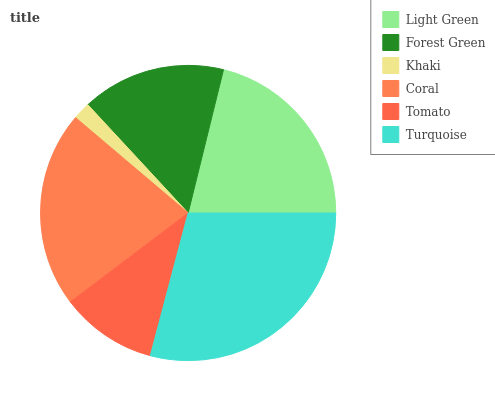Is Khaki the minimum?
Answer yes or no. Yes. Is Turquoise the maximum?
Answer yes or no. Yes. Is Forest Green the minimum?
Answer yes or no. No. Is Forest Green the maximum?
Answer yes or no. No. Is Light Green greater than Forest Green?
Answer yes or no. Yes. Is Forest Green less than Light Green?
Answer yes or no. Yes. Is Forest Green greater than Light Green?
Answer yes or no. No. Is Light Green less than Forest Green?
Answer yes or no. No. Is Light Green the high median?
Answer yes or no. Yes. Is Forest Green the low median?
Answer yes or no. Yes. Is Forest Green the high median?
Answer yes or no. No. Is Light Green the low median?
Answer yes or no. No. 